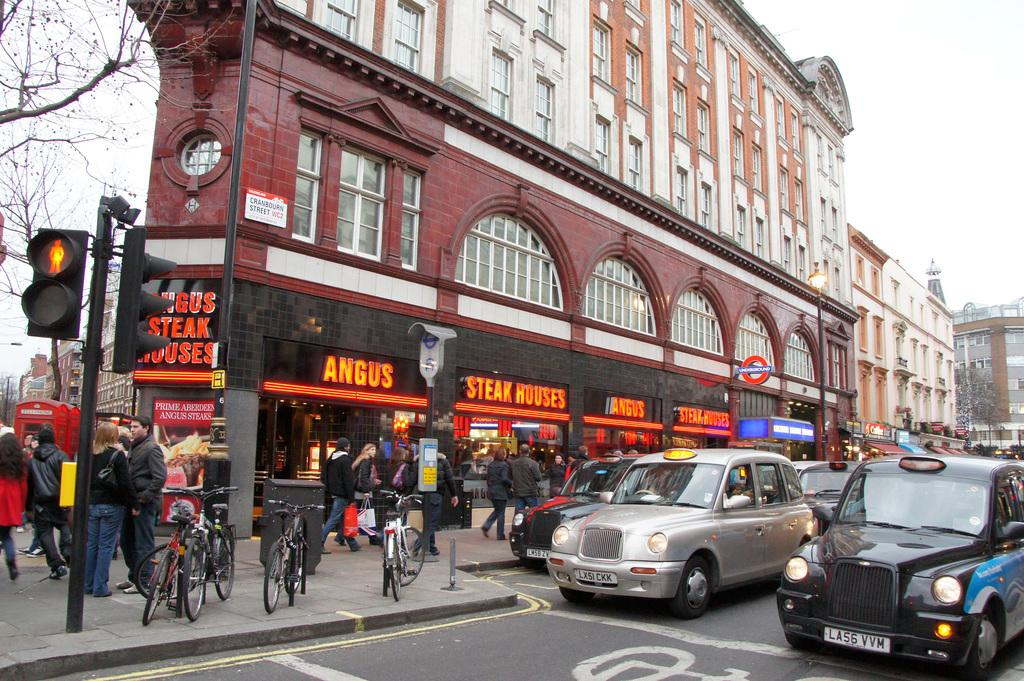<image>
Summarize the visual content of the image. The building on the corner is a restaurant for Angus Steakhouses. 